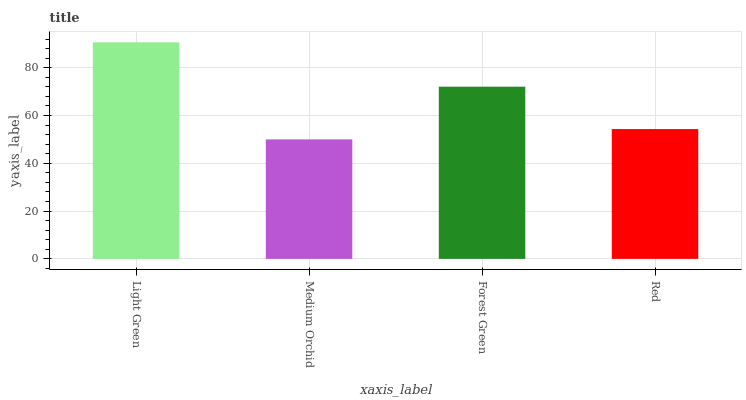Is Medium Orchid the minimum?
Answer yes or no. Yes. Is Light Green the maximum?
Answer yes or no. Yes. Is Forest Green the minimum?
Answer yes or no. No. Is Forest Green the maximum?
Answer yes or no. No. Is Forest Green greater than Medium Orchid?
Answer yes or no. Yes. Is Medium Orchid less than Forest Green?
Answer yes or no. Yes. Is Medium Orchid greater than Forest Green?
Answer yes or no. No. Is Forest Green less than Medium Orchid?
Answer yes or no. No. Is Forest Green the high median?
Answer yes or no. Yes. Is Red the low median?
Answer yes or no. Yes. Is Light Green the high median?
Answer yes or no. No. Is Medium Orchid the low median?
Answer yes or no. No. 